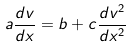Convert formula to latex. <formula><loc_0><loc_0><loc_500><loc_500>a \frac { d v } { d x } = b + c \frac { d v ^ { 2 } } { d x ^ { 2 } }</formula> 